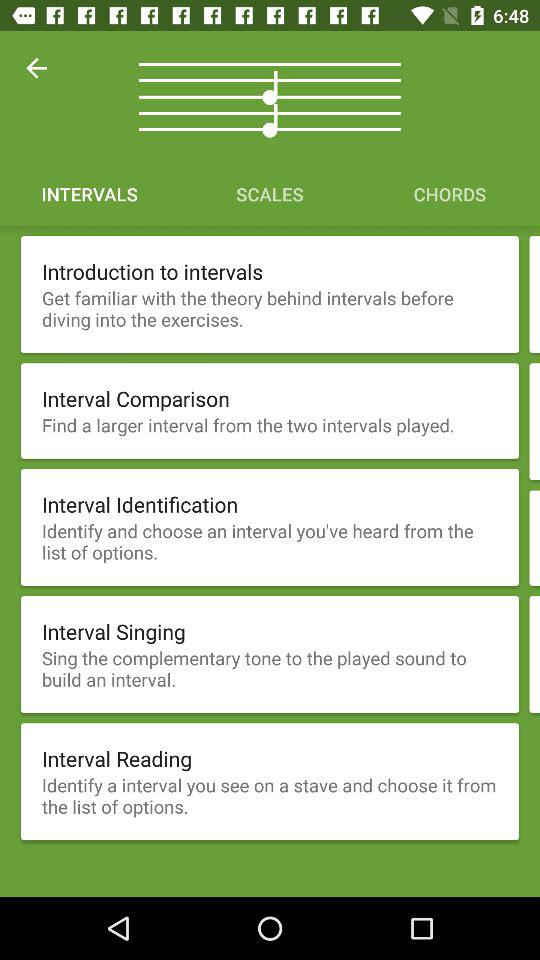Which tab is selected? The selected tab is "INTERVALS". 